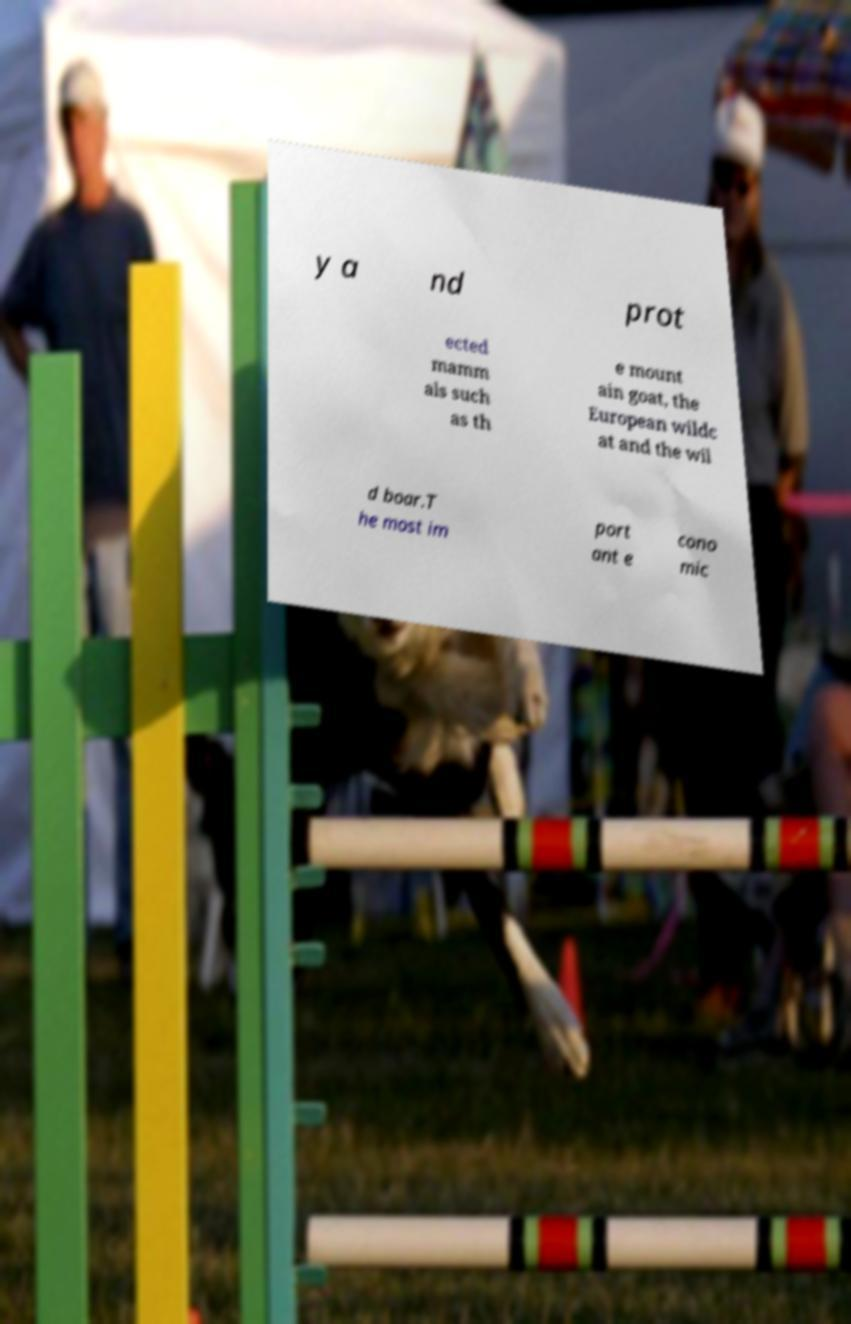There's text embedded in this image that I need extracted. Can you transcribe it verbatim? y a nd prot ected mamm als such as th e mount ain goat, the European wildc at and the wil d boar.T he most im port ant e cono mic 